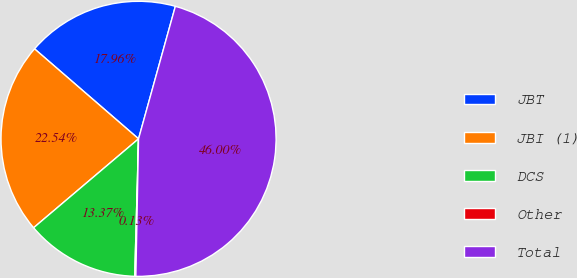Convert chart. <chart><loc_0><loc_0><loc_500><loc_500><pie_chart><fcel>JBT<fcel>JBI (1)<fcel>DCS<fcel>Other<fcel>Total<nl><fcel>17.96%<fcel>22.54%<fcel>13.37%<fcel>0.13%<fcel>46.0%<nl></chart> 